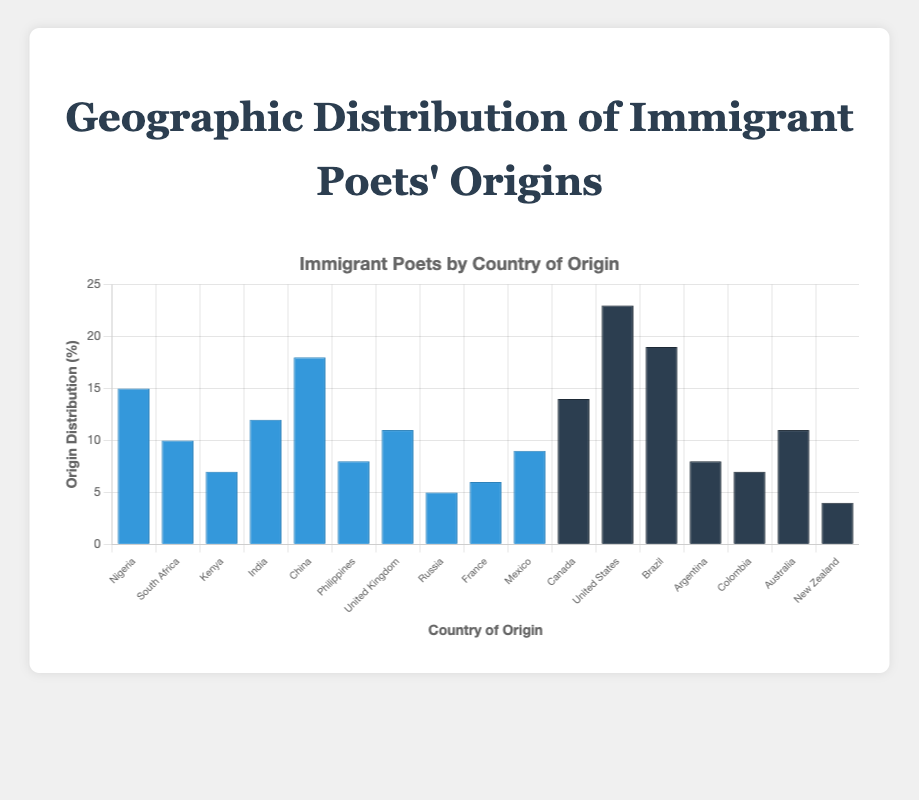What is the total origin distribution for North America? Add the origin distribution values for Mexico, Canada, and the United States: 9 + 14 + 23 = 46
Answer: 46 Which country has the highest origin distribution? The United States has the highest origin distribution of 23
Answer: The United States Which continents are represented by blue bars? The blue bars represent Africa, Asia, and Europe
Answer: Africa, Asia, and Europe What is the difference in origin distribution between Brazil and Argentina? Subtract Argentina's origin distribution from Brazil’s: 19 - 8 = 11
Answer: 11 Which country has the smallest number of immigrant poets? New Zealand has the smallest number of immigrant poets with a count of 1
Answer: New Zealand Which countries in Africa have a higher origin distribution than Kenya? Nigeria and South Africa have higher origin distributions than Kenya with values of 15 and 10 respectively, compared to Kenya's 7
Answer: Nigeria, South Africa What is the average origin distribution of countries in Oceania? Sum the origin distributions for Australia and New Zealand and divide by 2: (11 + 4) / 2 = 7.5
Answer: 7.5 How many countries have an origin distribution greater than 10? Count countries with an origin distribution greater than 10: Nigeria, India, China, United Kingdom, Canada, United States, Brazil (7 countries in total)
Answer: 7 What is the combined poet count for all the Asian countries? Add the poet counts for India, China, and the Philippines: 5 + 6 + 3 = 14
Answer: 14 Which region (continent) has the highest total origin distribution? Calculate the total origin distribution per continent and compare values. North America: 46, South America: 34, Asia: 38, Africa: 32, Europe: 22, Oceania: 15. The highest is North America with 46
Answer: North America 